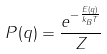<formula> <loc_0><loc_0><loc_500><loc_500>P ( q ) = \frac { e ^ { - \frac { E ( q ) } { k _ { B } T } } } { Z }</formula> 